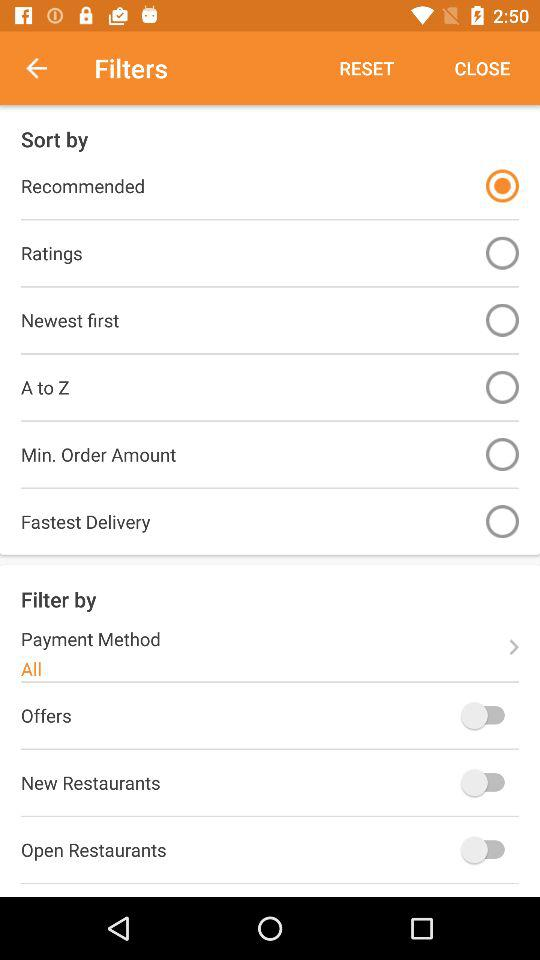What is the status of the "New Restaurants"? The status is "off". 